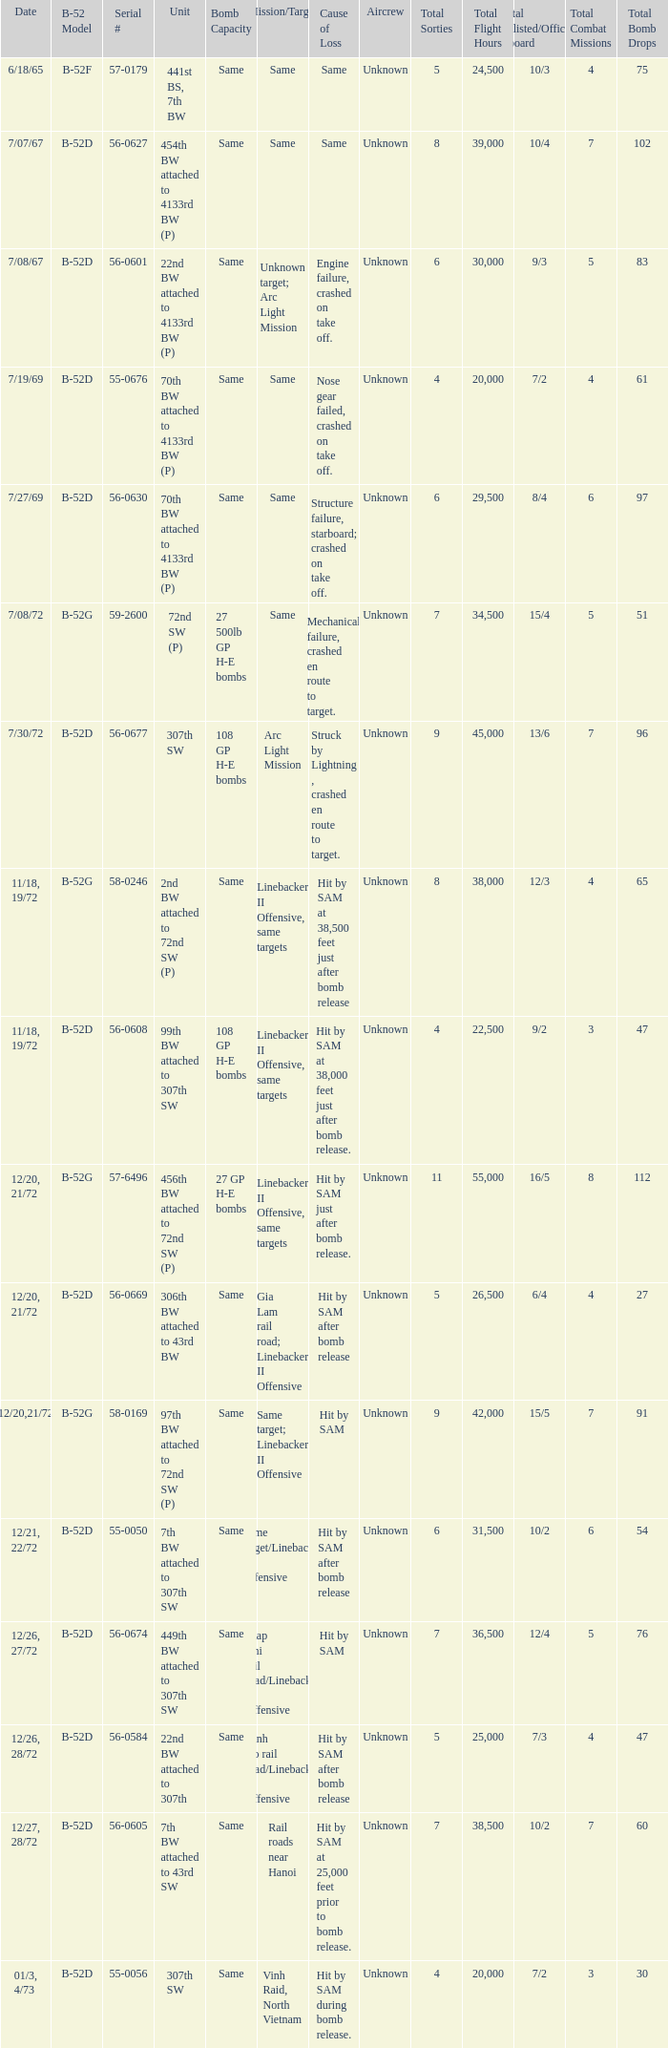When 441st bs, 7th bw is the unit what is the b-52 model? B-52F. 